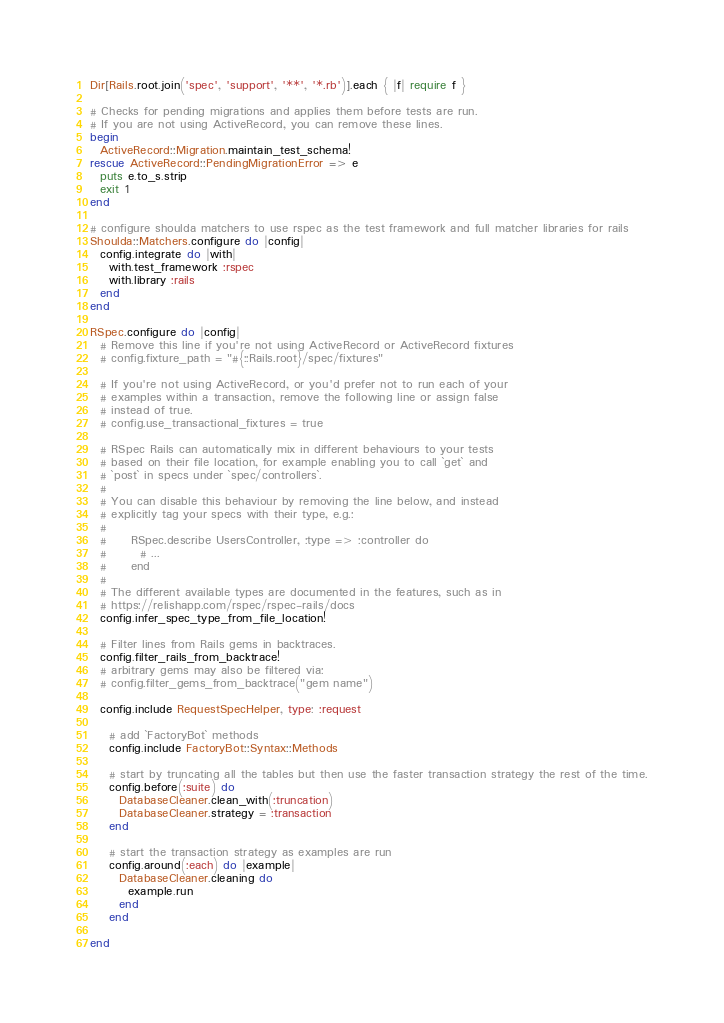<code> <loc_0><loc_0><loc_500><loc_500><_Ruby_>Dir[Rails.root.join('spec', 'support', '**', '*.rb')].each { |f| require f }

# Checks for pending migrations and applies them before tests are run.
# If you are not using ActiveRecord, you can remove these lines.
begin
  ActiveRecord::Migration.maintain_test_schema!
rescue ActiveRecord::PendingMigrationError => e
  puts e.to_s.strip
  exit 1
end

# configure shoulda matchers to use rspec as the test framework and full matcher libraries for rails
Shoulda::Matchers.configure do |config|
  config.integrate do |with|
    with.test_framework :rspec
    with.library :rails
  end
end

RSpec.configure do |config|
  # Remove this line if you're not using ActiveRecord or ActiveRecord fixtures
  # config.fixture_path = "#{::Rails.root}/spec/fixtures"

  # If you're not using ActiveRecord, or you'd prefer not to run each of your
  # examples within a transaction, remove the following line or assign false
  # instead of true.
  # config.use_transactional_fixtures = true

  # RSpec Rails can automatically mix in different behaviours to your tests
  # based on their file location, for example enabling you to call `get` and
  # `post` in specs under `spec/controllers`.
  #
  # You can disable this behaviour by removing the line below, and instead
  # explicitly tag your specs with their type, e.g.:
  #
  #     RSpec.describe UsersController, :type => :controller do
  #       # ...
  #     end
  #
  # The different available types are documented in the features, such as in
  # https://relishapp.com/rspec/rspec-rails/docs
  config.infer_spec_type_from_file_location!

  # Filter lines from Rails gems in backtraces.
  config.filter_rails_from_backtrace!
  # arbitrary gems may also be filtered via:
  # config.filter_gems_from_backtrace("gem name")

  config.include RequestSpecHelper, type: :request

    # add `FactoryBot` methods
    config.include FactoryBot::Syntax::Methods

    # start by truncating all the tables but then use the faster transaction strategy the rest of the time.
    config.before(:suite) do
      DatabaseCleaner.clean_with(:truncation)
      DatabaseCleaner.strategy = :transaction
    end
  
    # start the transaction strategy as examples are run
    config.around(:each) do |example|
      DatabaseCleaner.cleaning do
        example.run
      end
    end
  
end
</code> 